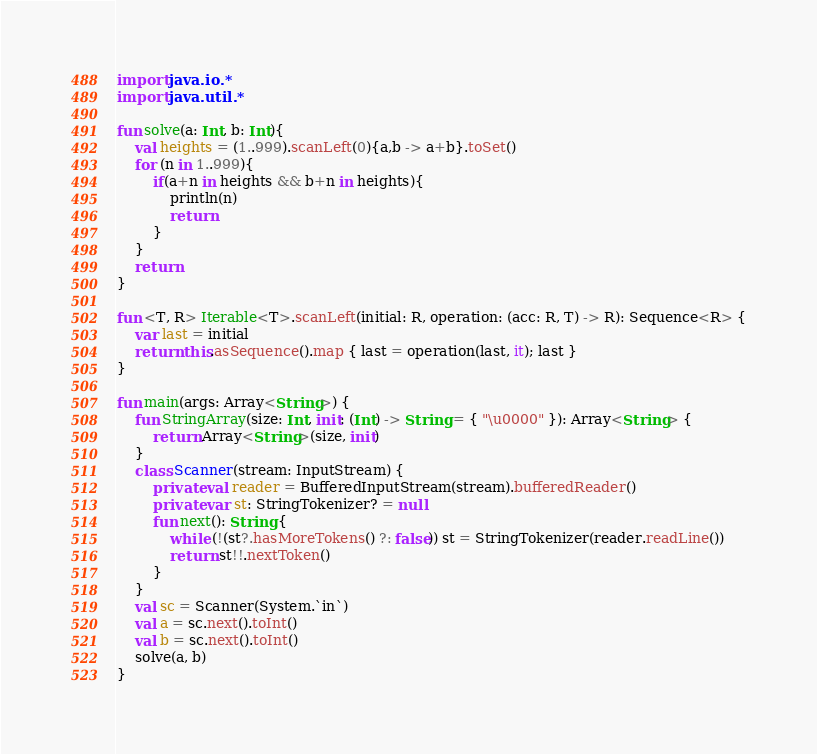<code> <loc_0><loc_0><loc_500><loc_500><_Kotlin_>import java.io.*
import java.util.*

fun solve(a: Int, b: Int){
    val heights = (1..999).scanLeft(0){a,b -> a+b}.toSet()
    for (n in 1..999){
        if(a+n in heights && b+n in heights){
            println(n)
            return
        }
    }
    return
}

fun <T, R> Iterable<T>.scanLeft(initial: R, operation: (acc: R, T) -> R): Sequence<R> {
    var last = initial
    return this.asSequence().map { last = operation(last, it); last }
}

fun main(args: Array<String>) {
    fun StringArray(size: Int, init: (Int) -> String = { "\u0000" }): Array<String> {
        return Array<String>(size, init)
    }
    class Scanner(stream: InputStream) {
        private val reader = BufferedInputStream(stream).bufferedReader()
        private var st: StringTokenizer? = null
        fun next(): String {
            while (!(st?.hasMoreTokens() ?: false)) st = StringTokenizer(reader.readLine())
            return st!!.nextToken()
        }
    }
    val sc = Scanner(System.`in`)
    val a = sc.next().toInt()
    val b = sc.next().toInt()
    solve(a, b)
}

</code> 